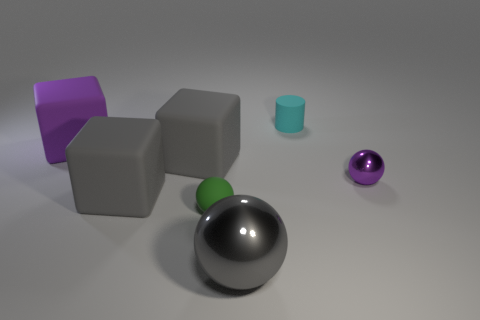Subtract all large gray blocks. How many blocks are left? 1 Subtract all red balls. How many gray cubes are left? 2 Add 3 big green balls. How many objects exist? 10 Subtract all gray spheres. How many spheres are left? 2 Subtract 1 blocks. How many blocks are left? 2 Subtract all cylinders. How many objects are left? 6 Subtract all blue spheres. Subtract all red cylinders. How many spheres are left? 3 Add 4 matte objects. How many matte objects are left? 9 Add 6 large gray shiny things. How many large gray shiny things exist? 7 Subtract 0 yellow blocks. How many objects are left? 7 